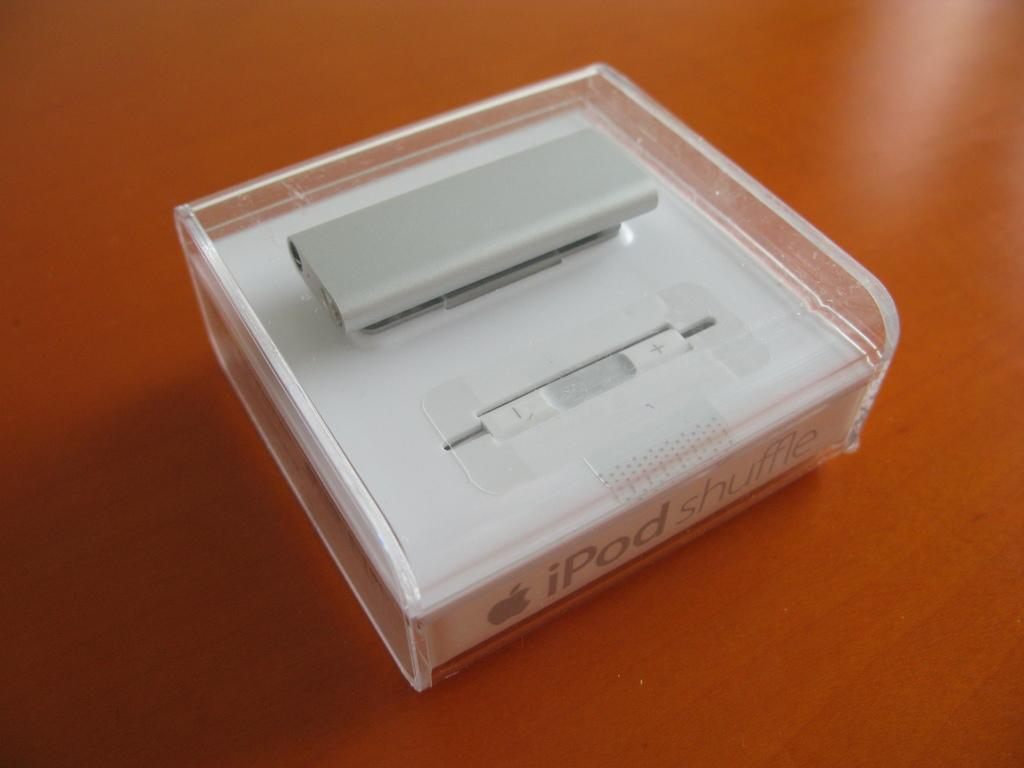<image>
Relay a brief, clear account of the picture shown. An iPod shuffle enclosed in a box rests on a wooden surface. 